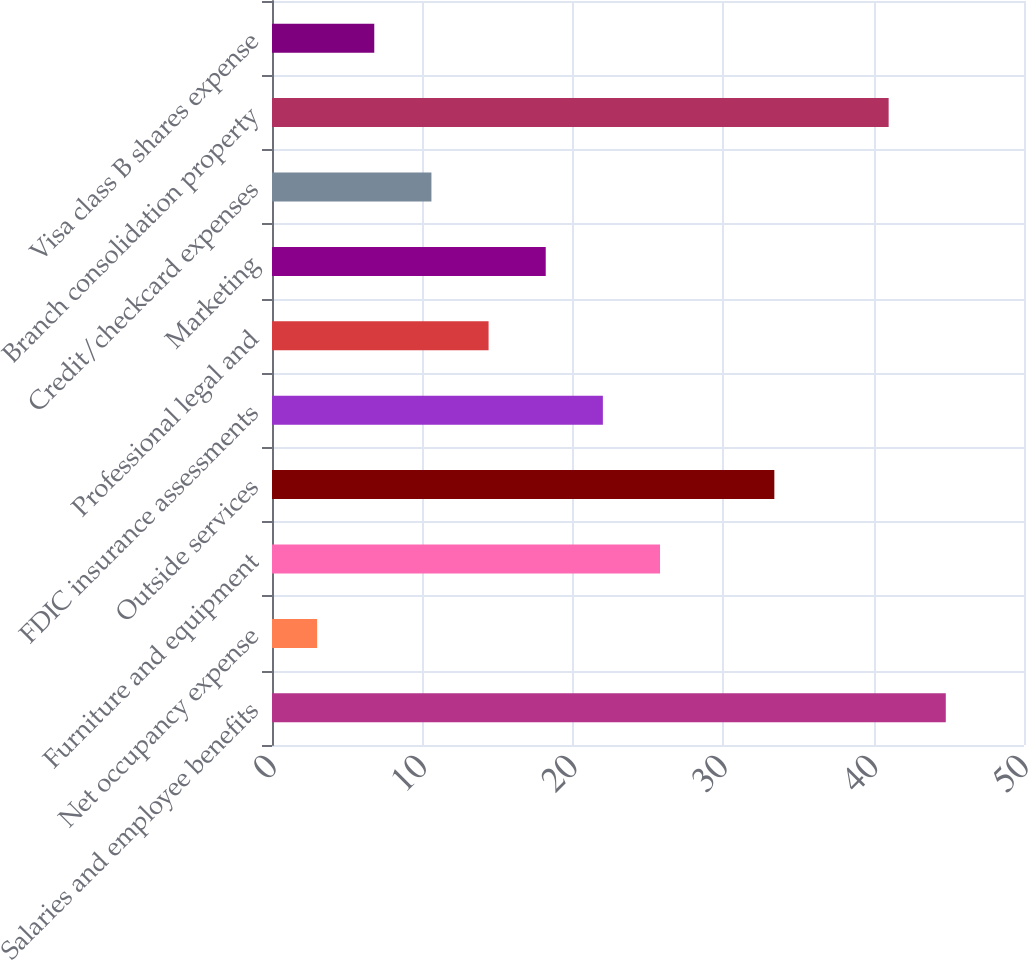Convert chart to OTSL. <chart><loc_0><loc_0><loc_500><loc_500><bar_chart><fcel>Salaries and employee benefits<fcel>Net occupancy expense<fcel>Furniture and equipment<fcel>Outside services<fcel>FDIC insurance assessments<fcel>Professional legal and<fcel>Marketing<fcel>Credit/checkcard expenses<fcel>Branch consolidation property<fcel>Visa class B shares expense<nl><fcel>44.8<fcel>3<fcel>25.8<fcel>33.4<fcel>22<fcel>14.4<fcel>18.2<fcel>10.6<fcel>41<fcel>6.8<nl></chart> 